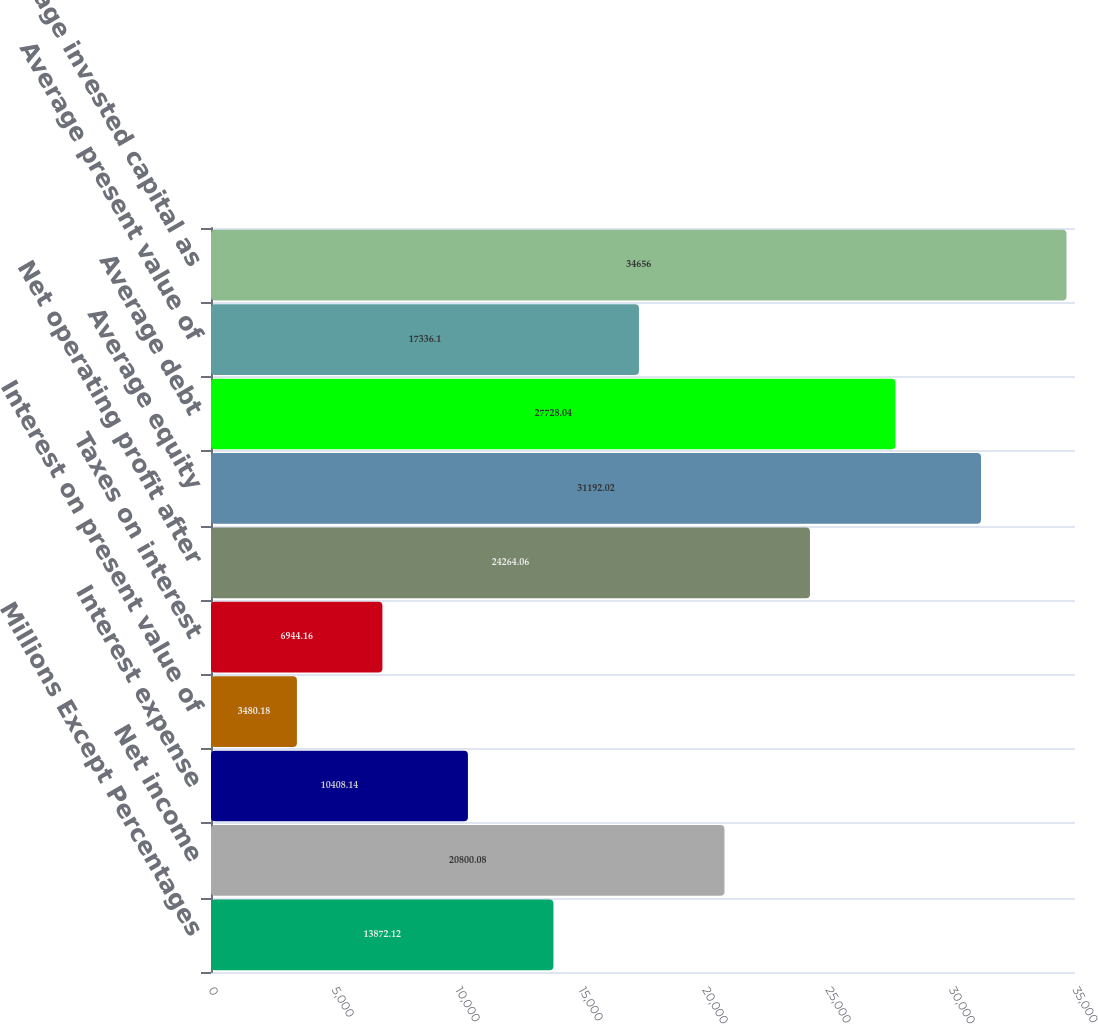<chart> <loc_0><loc_0><loc_500><loc_500><bar_chart><fcel>Millions Except Percentages<fcel>Net income<fcel>Interest expense<fcel>Interest on present value of<fcel>Taxes on interest<fcel>Net operating profit after<fcel>Average equity<fcel>Average debt<fcel>Average present value of<fcel>Average invested capital as<nl><fcel>13872.1<fcel>20800.1<fcel>10408.1<fcel>3480.18<fcel>6944.16<fcel>24264.1<fcel>31192<fcel>27728<fcel>17336.1<fcel>34656<nl></chart> 